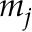Convert formula to latex. <formula><loc_0><loc_0><loc_500><loc_500>m _ { j }</formula> 